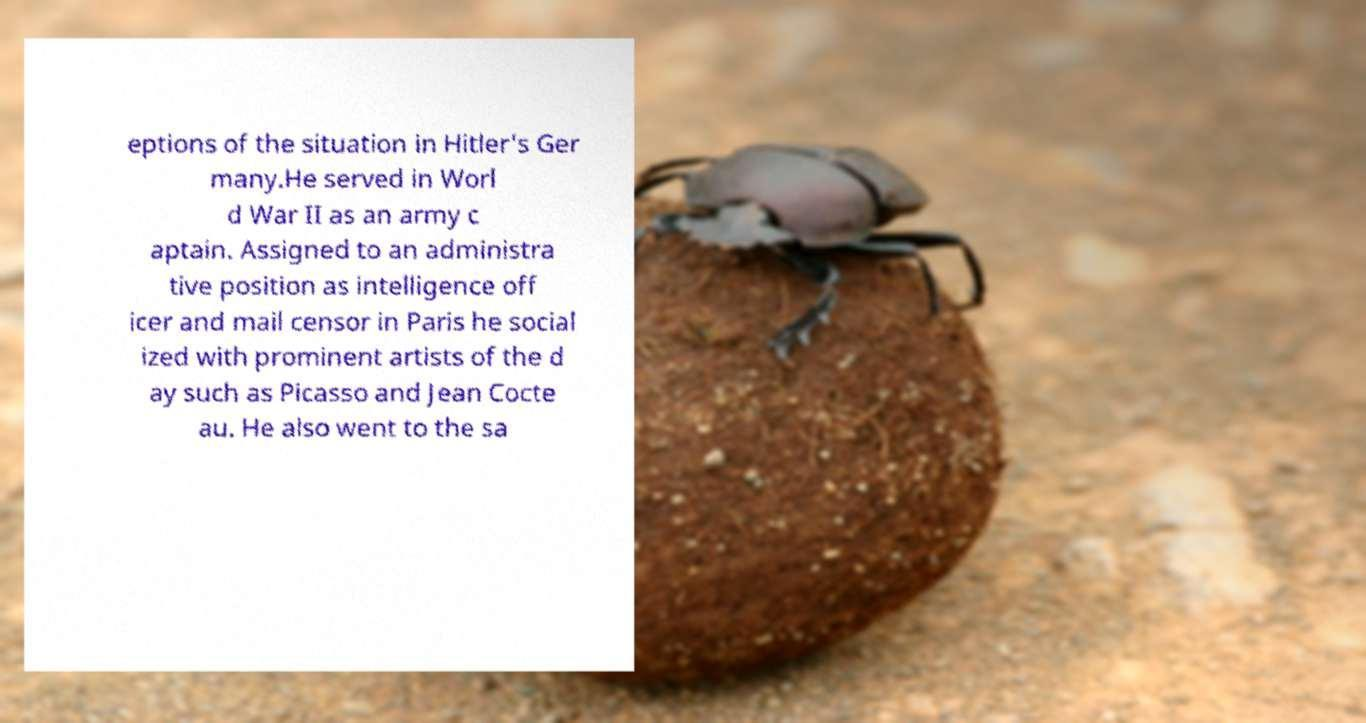Could you assist in decoding the text presented in this image and type it out clearly? eptions of the situation in Hitler's Ger many.He served in Worl d War II as an army c aptain. Assigned to an administra tive position as intelligence off icer and mail censor in Paris he social ized with prominent artists of the d ay such as Picasso and Jean Cocte au. He also went to the sa 